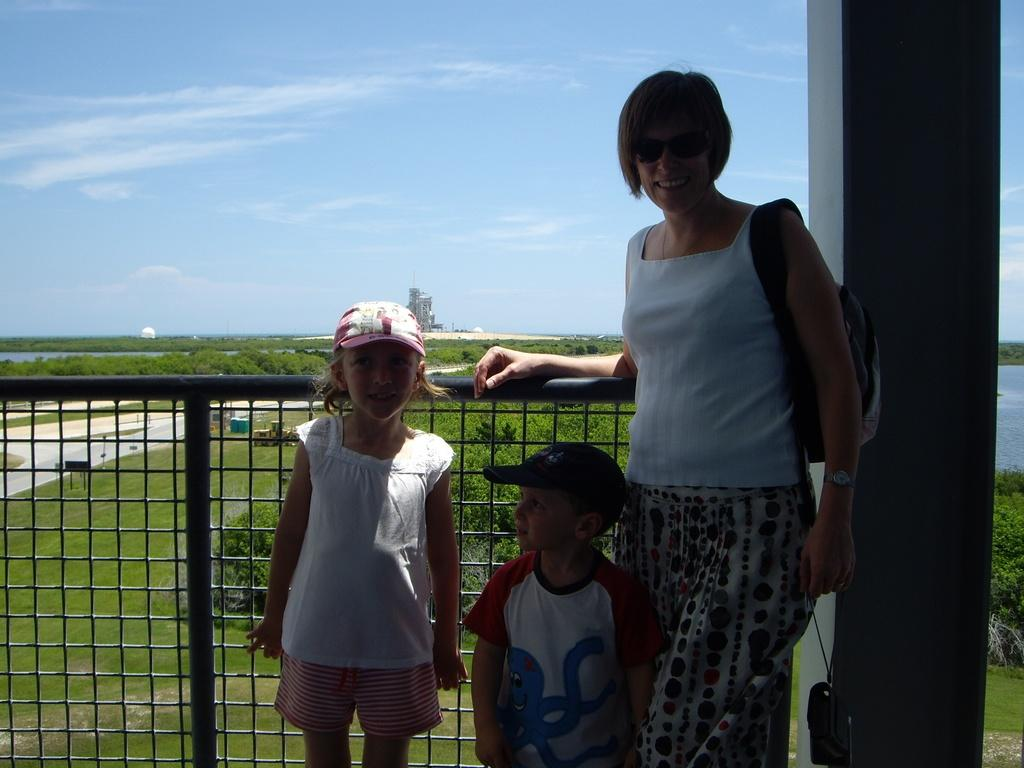How many people are present in the image? There are three people standing in the image. What can be seen on the right side of the image? There is a pillar on the right side of the image. What architectural feature is present in the image? There is a grille in the image. What is visible in the background of the image? Trees, a tower, and the sky are visible in the background of the image. What type of jelly is being used to repair the road in the image? There is no jelly or road present in the image; it features three people, a pillar, a grille, trees, a tower, and the sky. Who is the partner of the person standing next to the tower in the image? There is no indication of a partner or relationship between the people in the image, as the focus is on the number of people and the objects and features present. 